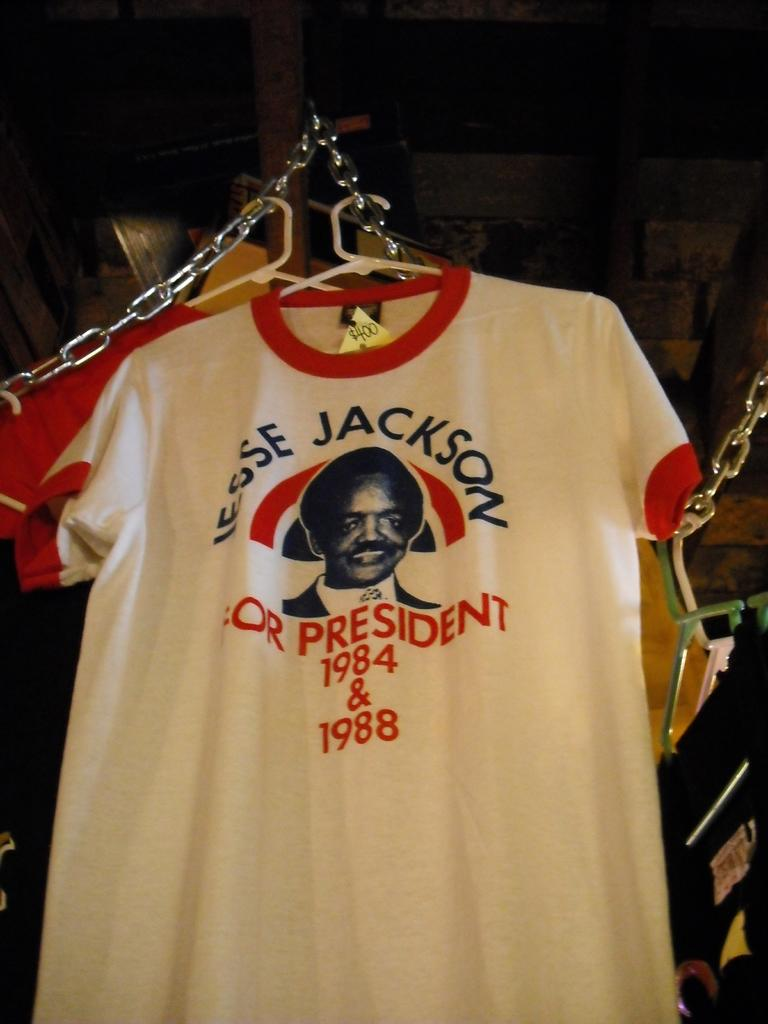<image>
Offer a succinct explanation of the picture presented. The shirt promotes Jesse Jackson for President in the 1980's. 